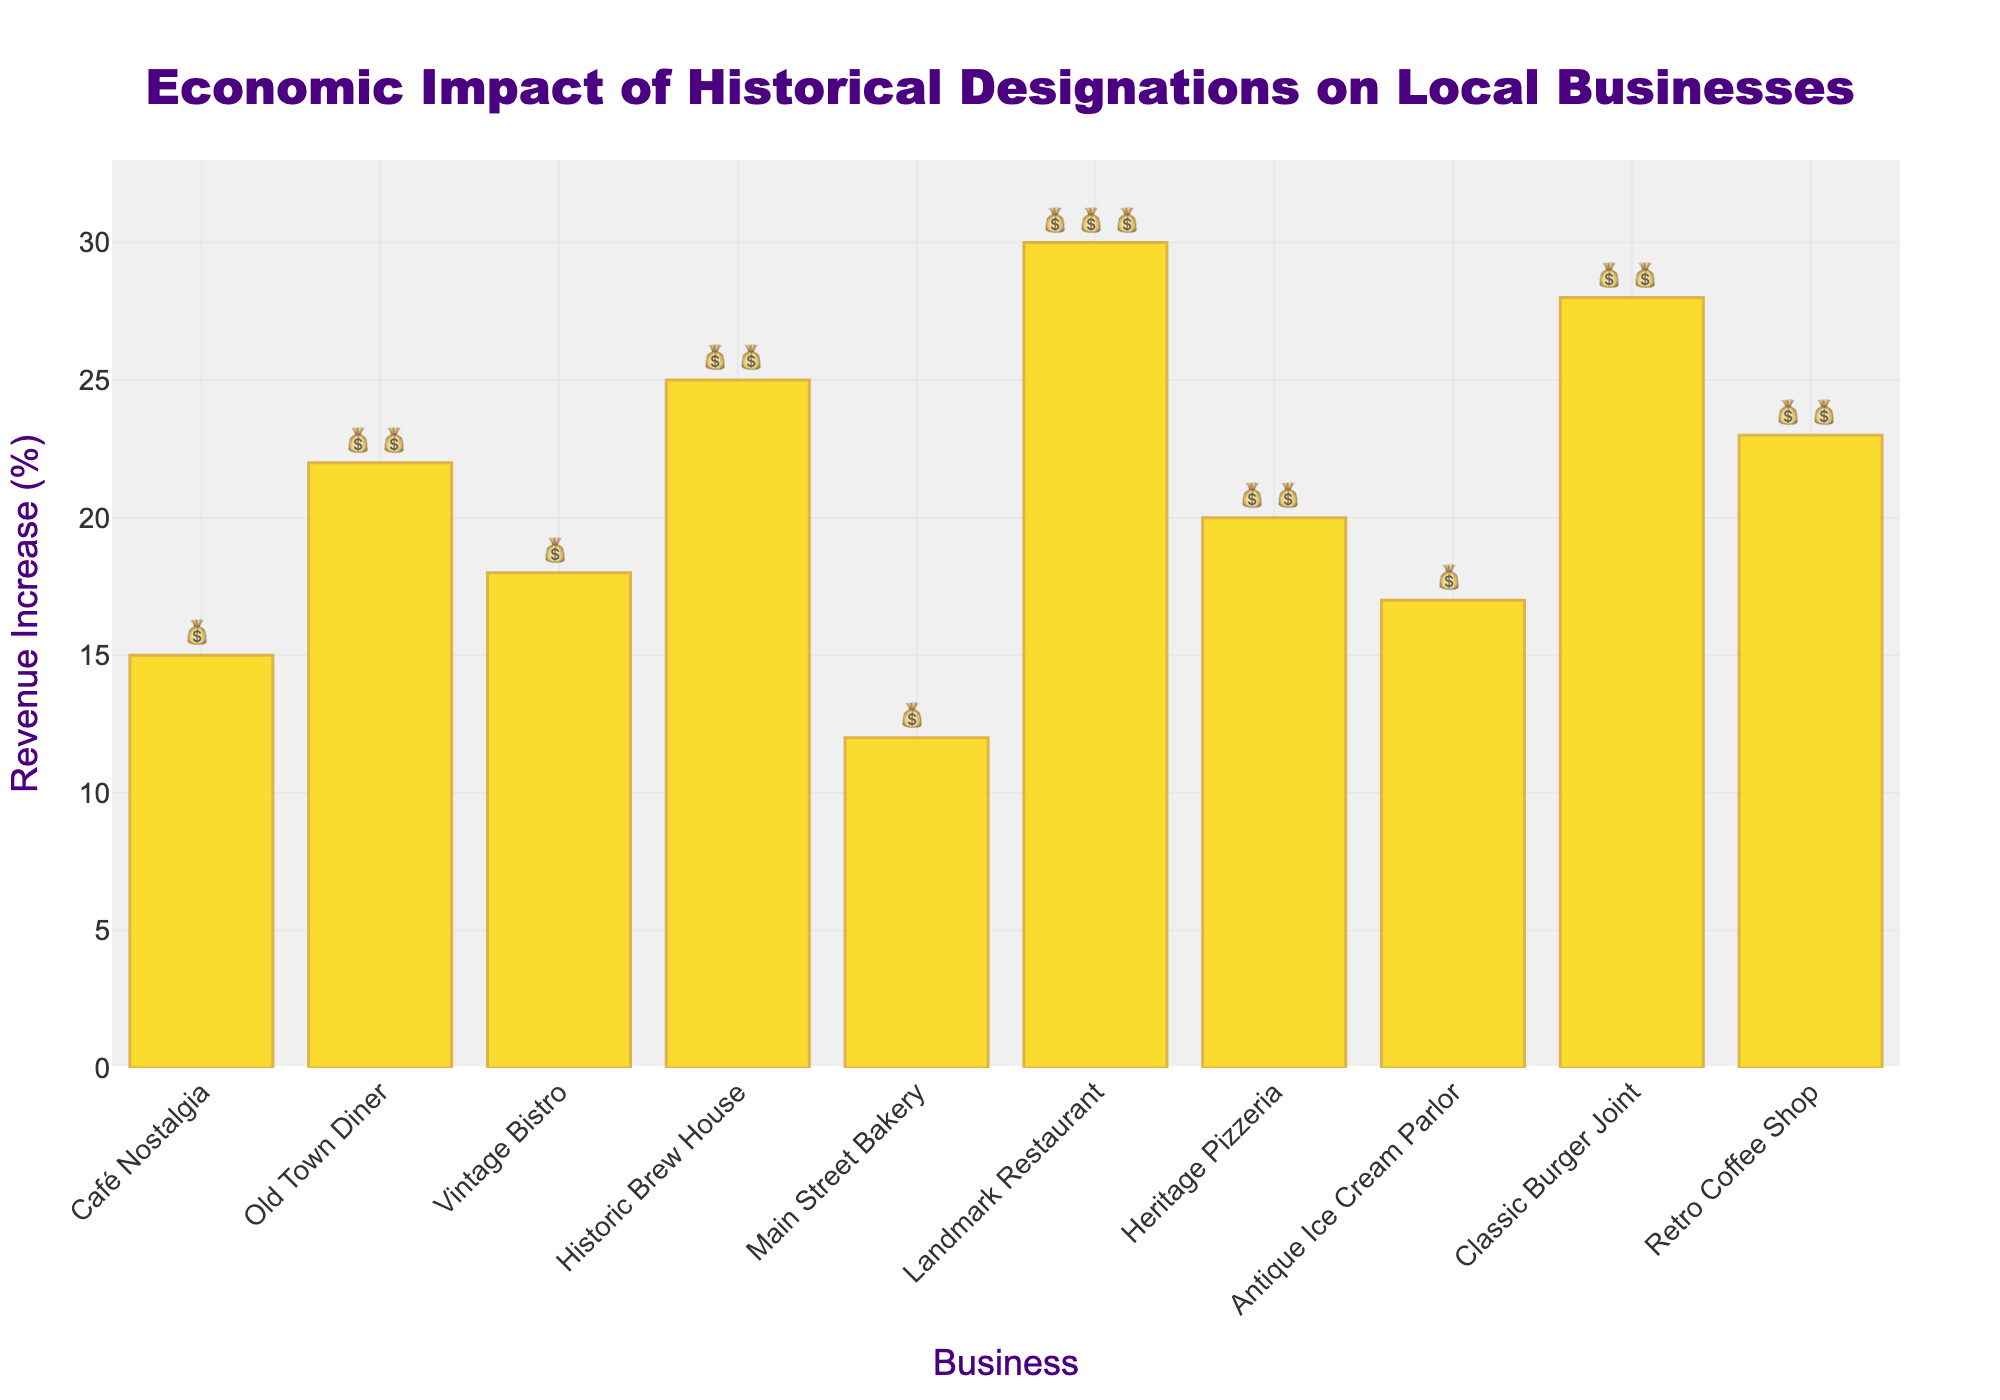What's the title of the chart? The title of the chart is displayed at the top center and reads, "Economic Impact of Historical Designations on Local Businesses".
Answer: Economic Impact of Historical Designations on Local Businesses What is the revenue increase percentage for the Landmark Restaurant? The Landmark Restaurant has a bar that reaches up to 30% on the y-axis.
Answer: 30% Which business has the highest Revenue Increase (%)? By looking at the tallest bar, it is evident that the Landmark Restaurant bar reaches the highest value at 30%.
Answer: Landmark Restaurant How many money bag emojis (💰) are associated with the Retro Coffee Shop? The text label for the Retro Coffee Shop bar shows 2 money bag emojis.
Answer: 2 What is the combined revenue increase percentage of Old Town Diner and Retro Coffee Shop? The Old Town Diner has a 22% revenue increase, and the Retro Coffee Shop has a 23% revenue increase. Adding them together gives 22 + 23 = 45.
Answer: 45% Which business has the smallest increase in revenue, and what is that percentage? The shortest bar belongs to Main Street Bakery, which shows a 12% increase.
Answer: Main Street Bakery, 12% How many businesses have a revenue increase percentage greater than or equal to 20%? By examining the bars, we see that there are five businesses: Old Town Diner (22%), Historic Brew House (25%), Landmark Restaurant (30%), Heritage Pizzeria (20%), and Retro Coffee Shop (23%).
Answer: 5 What is the total number of money bag emojis (💰) displayed on the chart? Counting the emojis for each business, we have: Café Nostalgia (1), Old Town Diner (2), Vintage Bistro (1), Historic Brew House (2), Main Street Bakery (1), Landmark Restaurant (3), Heritage Pizzeria (2), Antique Ice Cream Parlor (1), Classic Burger Joint (2), and Retro Coffee Shop (2), which totals to 1+2+1+2+1+3+2+1+2+2 = 17.
Answer: 17 What is the average revenue increase percentage across all businesses? Summing all revenue percentages: 15+22+18+25+12+30+20+17+28+23 = 210, then dividing by the number of businesses: 210/10 = 21%.
Answer: 21% 